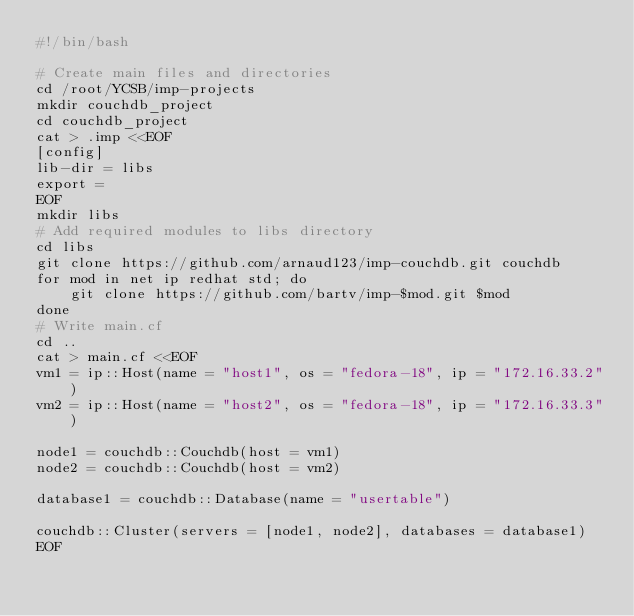<code> <loc_0><loc_0><loc_500><loc_500><_Bash_>#!/bin/bash

# Create main files and directories
cd /root/YCSB/imp-projects
mkdir couchdb_project
cd couchdb_project
cat > .imp <<EOF
[config]
lib-dir = libs
export = 
EOF
mkdir libs
# Add required modules to libs directory
cd libs
git clone https://github.com/arnaud123/imp-couchdb.git couchdb
for mod in net ip redhat std; do
    git clone https://github.com/bartv/imp-$mod.git $mod
done
# Write main.cf
cd ..
cat > main.cf <<EOF
vm1 = ip::Host(name = "host1", os = "fedora-18", ip = "172.16.33.2")
vm2 = ip::Host(name = "host2", os = "fedora-18", ip = "172.16.33.3")

node1 = couchdb::Couchdb(host = vm1)
node2 = couchdb::Couchdb(host = vm2)

database1 = couchdb::Database(name = "usertable")

couchdb::Cluster(servers = [node1, node2], databases = database1)
EOF
</code> 